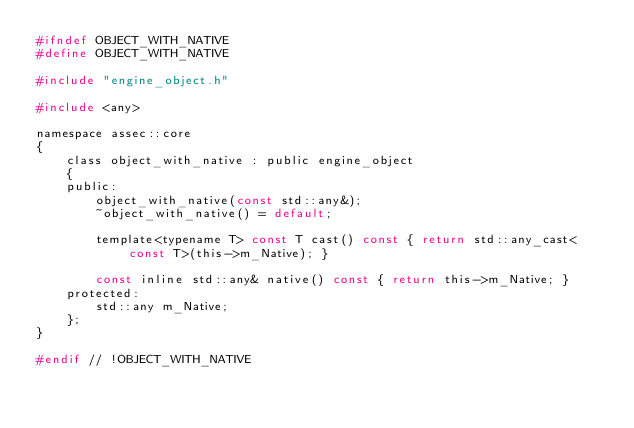<code> <loc_0><loc_0><loc_500><loc_500><_C_>#ifndef OBJECT_WITH_NATIVE
#define OBJECT_WITH_NATIVE

#include "engine_object.h"

#include <any>

namespace assec::core
{
	class object_with_native : public engine_object
	{
	public:
		object_with_native(const std::any&);
		~object_with_native() = default;

		template<typename T> const T cast() const { return std::any_cast<const T>(this->m_Native); }

		const inline std::any& native() const { return this->m_Native; }
	protected:
		std::any m_Native;
	};
}

#endif // !OBJECT_WITH_NATIVE</code> 